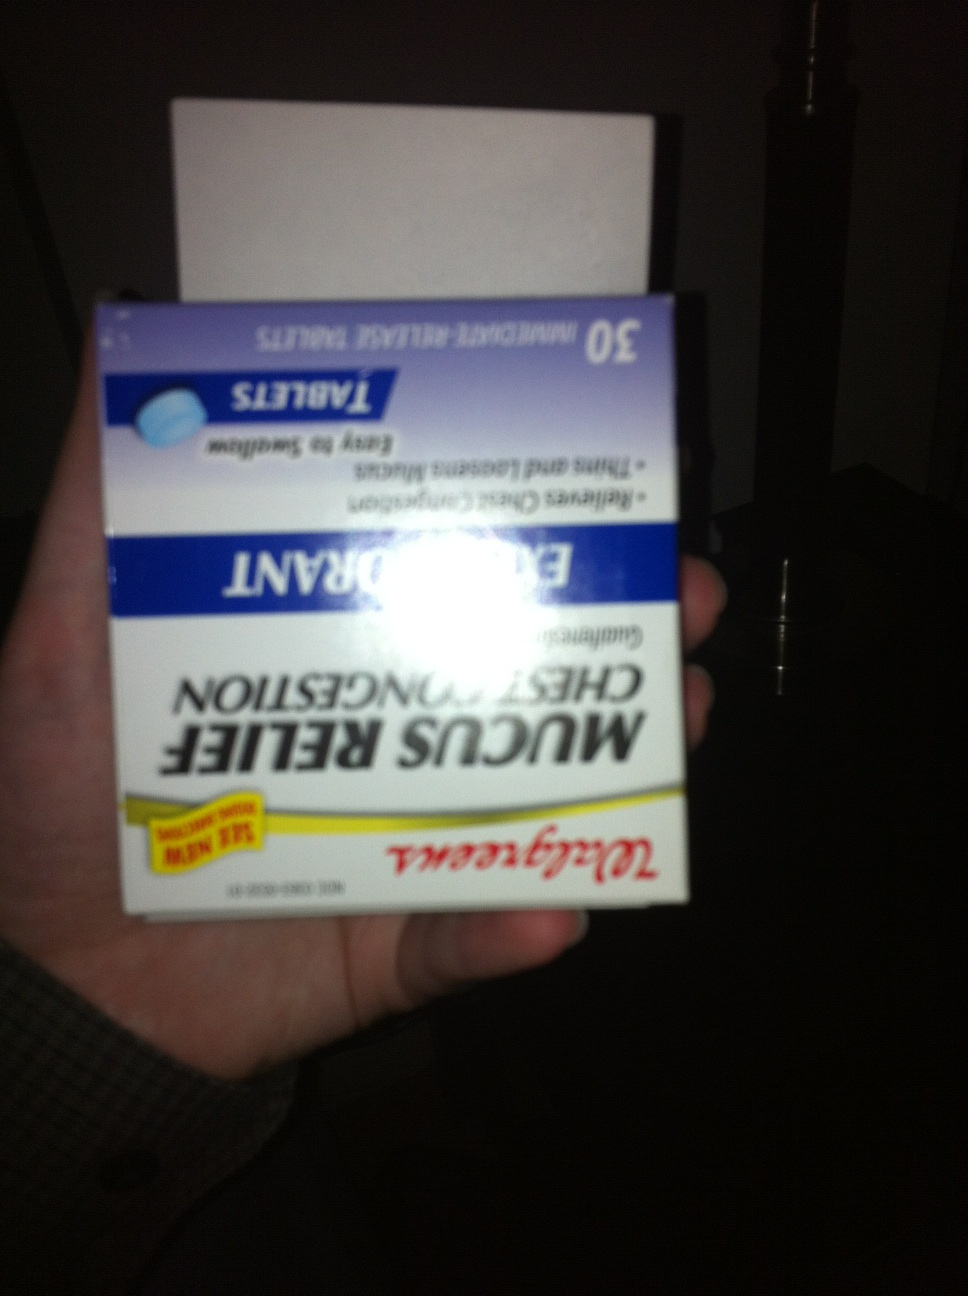What product is this? This is a box of Walgreens Mucus Relief Chest Congestion tablets. It contains 30 immediate-release tablets that help to loosen and thin mucus, making it easier to clear chest congestion and breathe more comfortably. 